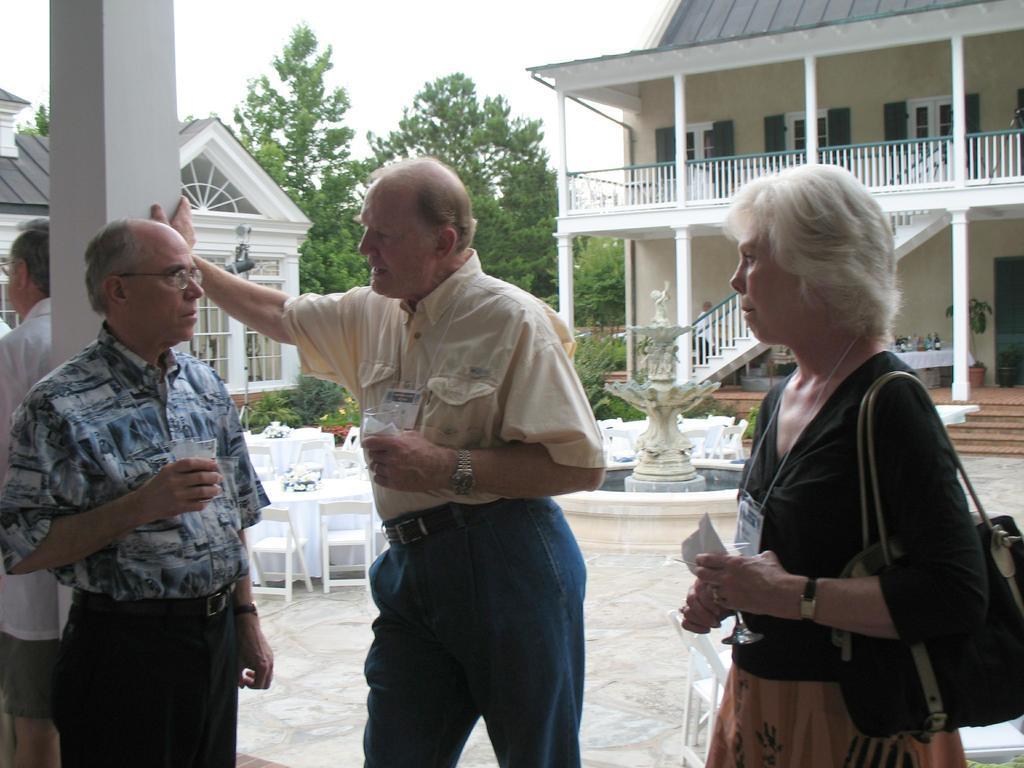In one or two sentences, can you explain what this image depicts? In this image there are people standing. There is a fountain. We can see chairs and tables. There are houses and trees in the background. We can see sky. 